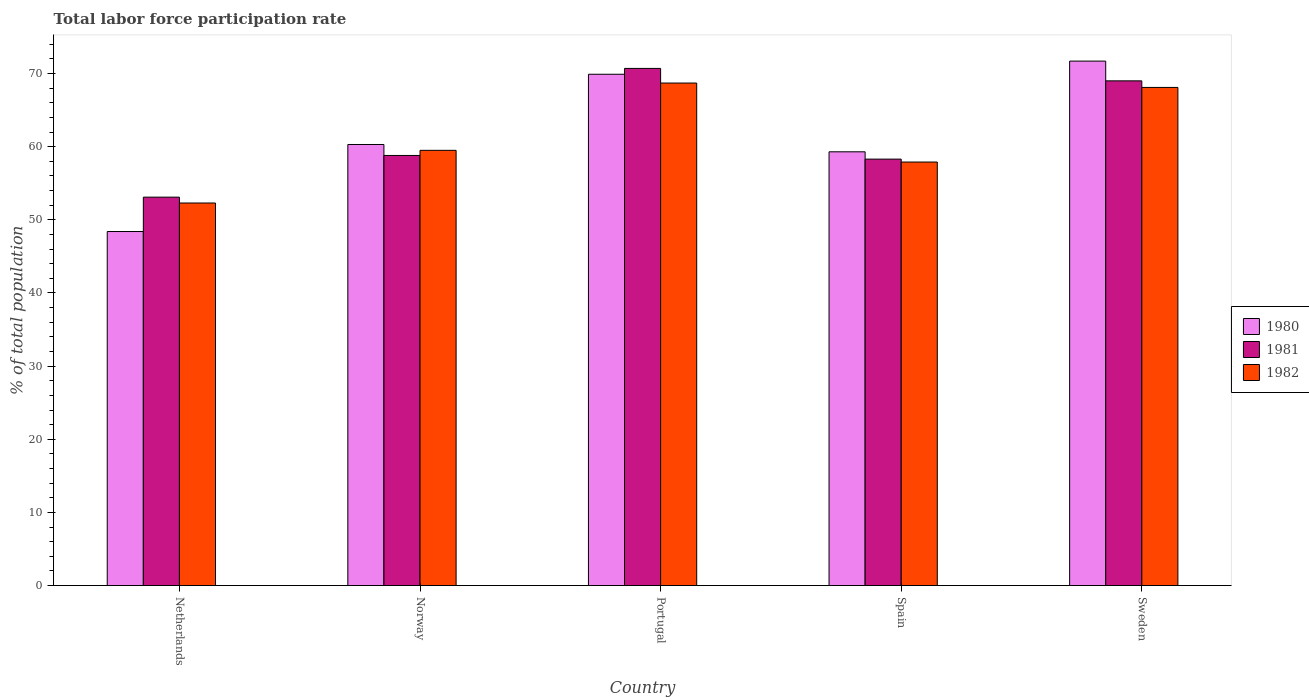How many different coloured bars are there?
Make the answer very short. 3. Are the number of bars per tick equal to the number of legend labels?
Your answer should be compact. Yes. How many bars are there on the 5th tick from the right?
Your response must be concise. 3. What is the label of the 4th group of bars from the left?
Your answer should be compact. Spain. What is the total labor force participation rate in 1981 in Spain?
Make the answer very short. 58.3. Across all countries, what is the maximum total labor force participation rate in 1982?
Offer a very short reply. 68.7. Across all countries, what is the minimum total labor force participation rate in 1981?
Make the answer very short. 53.1. In which country was the total labor force participation rate in 1981 minimum?
Ensure brevity in your answer.  Netherlands. What is the total total labor force participation rate in 1982 in the graph?
Your response must be concise. 306.5. What is the difference between the total labor force participation rate in 1982 in Netherlands and that in Sweden?
Ensure brevity in your answer.  -15.8. What is the difference between the total labor force participation rate in 1980 in Spain and the total labor force participation rate in 1982 in Norway?
Give a very brief answer. -0.2. What is the average total labor force participation rate in 1981 per country?
Your answer should be very brief. 61.98. What is the difference between the total labor force participation rate of/in 1980 and total labor force participation rate of/in 1981 in Netherlands?
Your response must be concise. -4.7. What is the ratio of the total labor force participation rate in 1981 in Netherlands to that in Spain?
Provide a succinct answer. 0.91. Is the total labor force participation rate in 1980 in Norway less than that in Spain?
Provide a succinct answer. No. Is the difference between the total labor force participation rate in 1980 in Netherlands and Spain greater than the difference between the total labor force participation rate in 1981 in Netherlands and Spain?
Your answer should be very brief. No. What is the difference between the highest and the second highest total labor force participation rate in 1982?
Offer a very short reply. -9.2. What is the difference between the highest and the lowest total labor force participation rate in 1980?
Make the answer very short. 23.3. What does the 3rd bar from the left in Netherlands represents?
Keep it short and to the point. 1982. Are all the bars in the graph horizontal?
Offer a terse response. No. What is the difference between two consecutive major ticks on the Y-axis?
Your answer should be compact. 10. Are the values on the major ticks of Y-axis written in scientific E-notation?
Make the answer very short. No. How many legend labels are there?
Provide a short and direct response. 3. How are the legend labels stacked?
Provide a succinct answer. Vertical. What is the title of the graph?
Ensure brevity in your answer.  Total labor force participation rate. What is the label or title of the X-axis?
Your answer should be very brief. Country. What is the label or title of the Y-axis?
Offer a terse response. % of total population. What is the % of total population of 1980 in Netherlands?
Ensure brevity in your answer.  48.4. What is the % of total population of 1981 in Netherlands?
Give a very brief answer. 53.1. What is the % of total population in 1982 in Netherlands?
Your answer should be compact. 52.3. What is the % of total population of 1980 in Norway?
Your answer should be very brief. 60.3. What is the % of total population of 1981 in Norway?
Make the answer very short. 58.8. What is the % of total population in 1982 in Norway?
Provide a short and direct response. 59.5. What is the % of total population of 1980 in Portugal?
Give a very brief answer. 69.9. What is the % of total population of 1981 in Portugal?
Keep it short and to the point. 70.7. What is the % of total population of 1982 in Portugal?
Your response must be concise. 68.7. What is the % of total population of 1980 in Spain?
Give a very brief answer. 59.3. What is the % of total population in 1981 in Spain?
Ensure brevity in your answer.  58.3. What is the % of total population of 1982 in Spain?
Ensure brevity in your answer.  57.9. What is the % of total population in 1980 in Sweden?
Offer a terse response. 71.7. What is the % of total population of 1981 in Sweden?
Your answer should be very brief. 69. What is the % of total population in 1982 in Sweden?
Offer a terse response. 68.1. Across all countries, what is the maximum % of total population in 1980?
Your answer should be very brief. 71.7. Across all countries, what is the maximum % of total population in 1981?
Your answer should be very brief. 70.7. Across all countries, what is the maximum % of total population of 1982?
Keep it short and to the point. 68.7. Across all countries, what is the minimum % of total population of 1980?
Provide a succinct answer. 48.4. Across all countries, what is the minimum % of total population of 1981?
Your answer should be very brief. 53.1. Across all countries, what is the minimum % of total population of 1982?
Provide a short and direct response. 52.3. What is the total % of total population of 1980 in the graph?
Ensure brevity in your answer.  309.6. What is the total % of total population in 1981 in the graph?
Your answer should be very brief. 309.9. What is the total % of total population of 1982 in the graph?
Keep it short and to the point. 306.5. What is the difference between the % of total population in 1980 in Netherlands and that in Norway?
Ensure brevity in your answer.  -11.9. What is the difference between the % of total population in 1982 in Netherlands and that in Norway?
Your answer should be compact. -7.2. What is the difference between the % of total population of 1980 in Netherlands and that in Portugal?
Give a very brief answer. -21.5. What is the difference between the % of total population of 1981 in Netherlands and that in Portugal?
Your answer should be compact. -17.6. What is the difference between the % of total population of 1982 in Netherlands and that in Portugal?
Give a very brief answer. -16.4. What is the difference between the % of total population of 1980 in Netherlands and that in Spain?
Ensure brevity in your answer.  -10.9. What is the difference between the % of total population in 1980 in Netherlands and that in Sweden?
Your answer should be very brief. -23.3. What is the difference between the % of total population of 1981 in Netherlands and that in Sweden?
Your answer should be compact. -15.9. What is the difference between the % of total population of 1982 in Netherlands and that in Sweden?
Provide a succinct answer. -15.8. What is the difference between the % of total population of 1980 in Norway and that in Spain?
Keep it short and to the point. 1. What is the difference between the % of total population of 1981 in Norway and that in Spain?
Provide a succinct answer. 0.5. What is the difference between the % of total population of 1980 in Norway and that in Sweden?
Offer a terse response. -11.4. What is the difference between the % of total population in 1981 in Norway and that in Sweden?
Offer a very short reply. -10.2. What is the difference between the % of total population in 1981 in Portugal and that in Spain?
Your answer should be compact. 12.4. What is the difference between the % of total population of 1980 in Portugal and that in Sweden?
Ensure brevity in your answer.  -1.8. What is the difference between the % of total population in 1981 in Portugal and that in Sweden?
Offer a terse response. 1.7. What is the difference between the % of total population in 1982 in Portugal and that in Sweden?
Keep it short and to the point. 0.6. What is the difference between the % of total population of 1980 in Spain and that in Sweden?
Ensure brevity in your answer.  -12.4. What is the difference between the % of total population in 1981 in Spain and that in Sweden?
Keep it short and to the point. -10.7. What is the difference between the % of total population in 1982 in Spain and that in Sweden?
Provide a short and direct response. -10.2. What is the difference between the % of total population in 1980 in Netherlands and the % of total population in 1981 in Norway?
Keep it short and to the point. -10.4. What is the difference between the % of total population in 1980 in Netherlands and the % of total population in 1982 in Norway?
Give a very brief answer. -11.1. What is the difference between the % of total population in 1980 in Netherlands and the % of total population in 1981 in Portugal?
Offer a terse response. -22.3. What is the difference between the % of total population in 1980 in Netherlands and the % of total population in 1982 in Portugal?
Ensure brevity in your answer.  -20.3. What is the difference between the % of total population of 1981 in Netherlands and the % of total population of 1982 in Portugal?
Give a very brief answer. -15.6. What is the difference between the % of total population in 1981 in Netherlands and the % of total population in 1982 in Spain?
Your answer should be very brief. -4.8. What is the difference between the % of total population of 1980 in Netherlands and the % of total population of 1981 in Sweden?
Keep it short and to the point. -20.6. What is the difference between the % of total population in 1980 in Netherlands and the % of total population in 1982 in Sweden?
Provide a short and direct response. -19.7. What is the difference between the % of total population in 1981 in Netherlands and the % of total population in 1982 in Sweden?
Ensure brevity in your answer.  -15. What is the difference between the % of total population in 1980 in Norway and the % of total population in 1981 in Portugal?
Make the answer very short. -10.4. What is the difference between the % of total population of 1981 in Norway and the % of total population of 1982 in Spain?
Your response must be concise. 0.9. What is the difference between the % of total population in 1980 in Norway and the % of total population in 1981 in Sweden?
Ensure brevity in your answer.  -8.7. What is the difference between the % of total population in 1980 in Norway and the % of total population in 1982 in Sweden?
Provide a succinct answer. -7.8. What is the difference between the % of total population in 1980 in Portugal and the % of total population in 1982 in Spain?
Provide a succinct answer. 12. What is the difference between the % of total population of 1981 in Portugal and the % of total population of 1982 in Spain?
Keep it short and to the point. 12.8. What is the difference between the % of total population of 1980 in Portugal and the % of total population of 1982 in Sweden?
Your response must be concise. 1.8. What is the difference between the % of total population of 1980 in Spain and the % of total population of 1981 in Sweden?
Offer a very short reply. -9.7. What is the difference between the % of total population in 1981 in Spain and the % of total population in 1982 in Sweden?
Provide a succinct answer. -9.8. What is the average % of total population of 1980 per country?
Give a very brief answer. 61.92. What is the average % of total population of 1981 per country?
Offer a terse response. 61.98. What is the average % of total population of 1982 per country?
Ensure brevity in your answer.  61.3. What is the difference between the % of total population of 1980 and % of total population of 1981 in Netherlands?
Provide a succinct answer. -4.7. What is the difference between the % of total population in 1981 and % of total population in 1982 in Netherlands?
Ensure brevity in your answer.  0.8. What is the difference between the % of total population of 1980 and % of total population of 1982 in Norway?
Keep it short and to the point. 0.8. What is the difference between the % of total population in 1981 and % of total population in 1982 in Norway?
Make the answer very short. -0.7. What is the difference between the % of total population in 1980 and % of total population in 1981 in Portugal?
Offer a very short reply. -0.8. What is the difference between the % of total population in 1981 and % of total population in 1982 in Portugal?
Your answer should be very brief. 2. What is the difference between the % of total population in 1980 and % of total population in 1982 in Spain?
Provide a short and direct response. 1.4. What is the ratio of the % of total population of 1980 in Netherlands to that in Norway?
Your response must be concise. 0.8. What is the ratio of the % of total population of 1981 in Netherlands to that in Norway?
Your answer should be very brief. 0.9. What is the ratio of the % of total population of 1982 in Netherlands to that in Norway?
Offer a very short reply. 0.88. What is the ratio of the % of total population in 1980 in Netherlands to that in Portugal?
Offer a very short reply. 0.69. What is the ratio of the % of total population in 1981 in Netherlands to that in Portugal?
Make the answer very short. 0.75. What is the ratio of the % of total population in 1982 in Netherlands to that in Portugal?
Make the answer very short. 0.76. What is the ratio of the % of total population of 1980 in Netherlands to that in Spain?
Your answer should be compact. 0.82. What is the ratio of the % of total population in 1981 in Netherlands to that in Spain?
Offer a terse response. 0.91. What is the ratio of the % of total population of 1982 in Netherlands to that in Spain?
Provide a short and direct response. 0.9. What is the ratio of the % of total population in 1980 in Netherlands to that in Sweden?
Ensure brevity in your answer.  0.68. What is the ratio of the % of total population of 1981 in Netherlands to that in Sweden?
Your answer should be compact. 0.77. What is the ratio of the % of total population of 1982 in Netherlands to that in Sweden?
Give a very brief answer. 0.77. What is the ratio of the % of total population in 1980 in Norway to that in Portugal?
Your answer should be very brief. 0.86. What is the ratio of the % of total population in 1981 in Norway to that in Portugal?
Make the answer very short. 0.83. What is the ratio of the % of total population in 1982 in Norway to that in Portugal?
Ensure brevity in your answer.  0.87. What is the ratio of the % of total population of 1980 in Norway to that in Spain?
Provide a short and direct response. 1.02. What is the ratio of the % of total population of 1981 in Norway to that in Spain?
Your answer should be very brief. 1.01. What is the ratio of the % of total population of 1982 in Norway to that in Spain?
Your response must be concise. 1.03. What is the ratio of the % of total population in 1980 in Norway to that in Sweden?
Make the answer very short. 0.84. What is the ratio of the % of total population in 1981 in Norway to that in Sweden?
Keep it short and to the point. 0.85. What is the ratio of the % of total population in 1982 in Norway to that in Sweden?
Offer a very short reply. 0.87. What is the ratio of the % of total population in 1980 in Portugal to that in Spain?
Offer a terse response. 1.18. What is the ratio of the % of total population in 1981 in Portugal to that in Spain?
Your answer should be compact. 1.21. What is the ratio of the % of total population in 1982 in Portugal to that in Spain?
Your answer should be compact. 1.19. What is the ratio of the % of total population in 1980 in Portugal to that in Sweden?
Ensure brevity in your answer.  0.97. What is the ratio of the % of total population in 1981 in Portugal to that in Sweden?
Offer a very short reply. 1.02. What is the ratio of the % of total population in 1982 in Portugal to that in Sweden?
Provide a short and direct response. 1.01. What is the ratio of the % of total population in 1980 in Spain to that in Sweden?
Make the answer very short. 0.83. What is the ratio of the % of total population in 1981 in Spain to that in Sweden?
Offer a terse response. 0.84. What is the ratio of the % of total population of 1982 in Spain to that in Sweden?
Ensure brevity in your answer.  0.85. What is the difference between the highest and the second highest % of total population of 1980?
Ensure brevity in your answer.  1.8. What is the difference between the highest and the second highest % of total population of 1981?
Your response must be concise. 1.7. What is the difference between the highest and the lowest % of total population in 1980?
Provide a short and direct response. 23.3. 